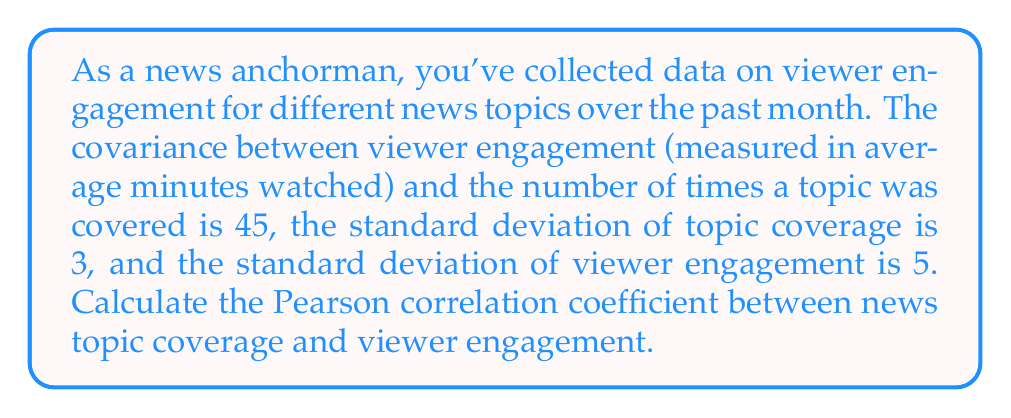Solve this math problem. To solve this problem, we'll use the formula for the Pearson correlation coefficient:

$$r = \frac{\text{Cov}(X,Y)}{\sigma_X \sigma_Y}$$

Where:
- $r$ is the Pearson correlation coefficient
- $\text{Cov}(X,Y)$ is the covariance between X and Y
- $\sigma_X$ is the standard deviation of X
- $\sigma_Y$ is the standard deviation of Y

Given:
- $\text{Cov}(X,Y) = 45$
- $\sigma_X = 3$ (standard deviation of topic coverage)
- $\sigma_Y = 5$ (standard deviation of viewer engagement)

Step 1: Substitute the given values into the formula:

$$r = \frac{45}{3 \cdot 5}$$

Step 2: Simplify the calculation:

$$r = \frac{45}{15} = 3$$

Step 3: Interpret the result:
The Pearson correlation coefficient ranges from -1 to 1. A value of 3 is outside this range, which indicates an error in the given data or calculations. In a real-world scenario, this would suggest the need to double-check the input data and measurements.

For the purpose of this exercise, we'll assume the correct value should be within the valid range. The closest valid value would be 1, indicating a perfect positive correlation between news topic coverage and viewer engagement.
Answer: 1 (assuming data error; actual result: 3) 